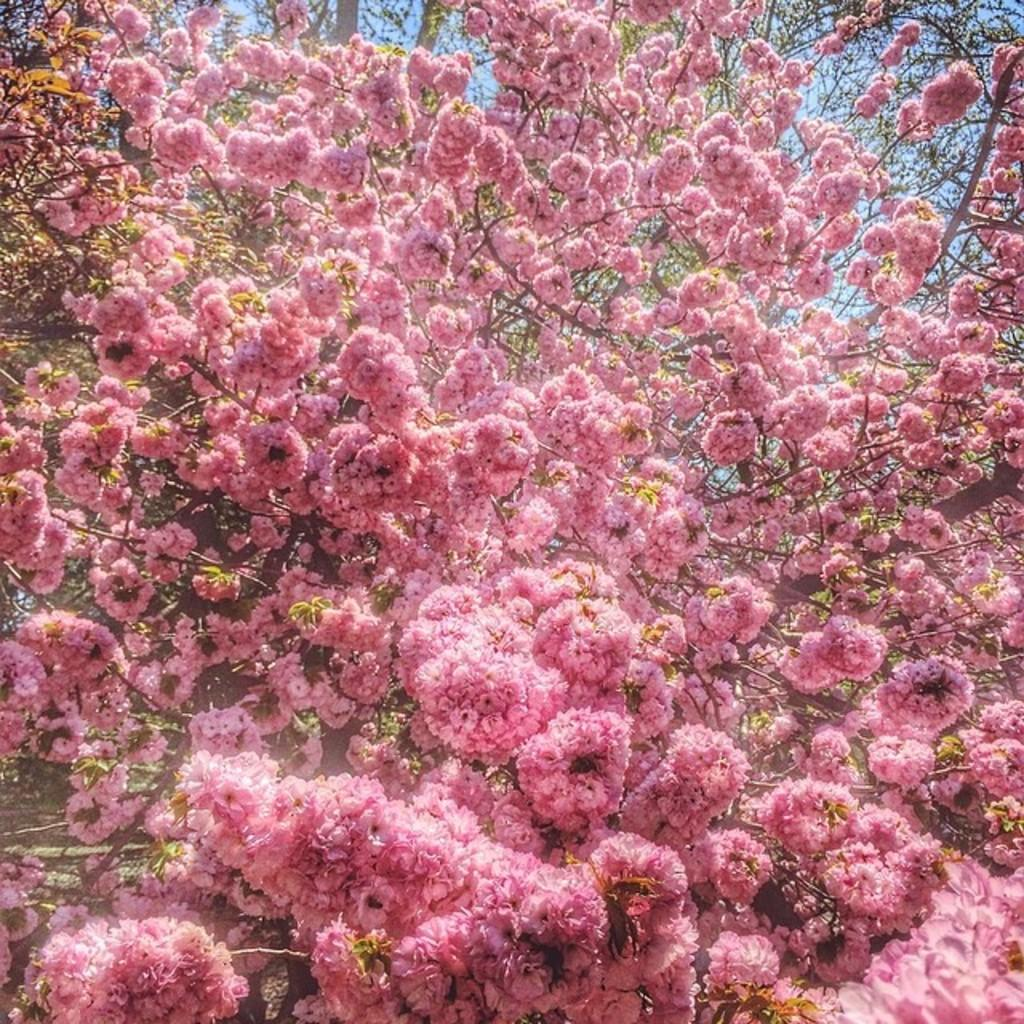What type of trees are present in the image? There are pink flower trees in the image. What can be seen in the background of the image? The sky is visible in the image. How many eggs can be seen in the stomach of the bear in the image? There is no bear or eggs present in the image; it features pink flower trees and the sky. 